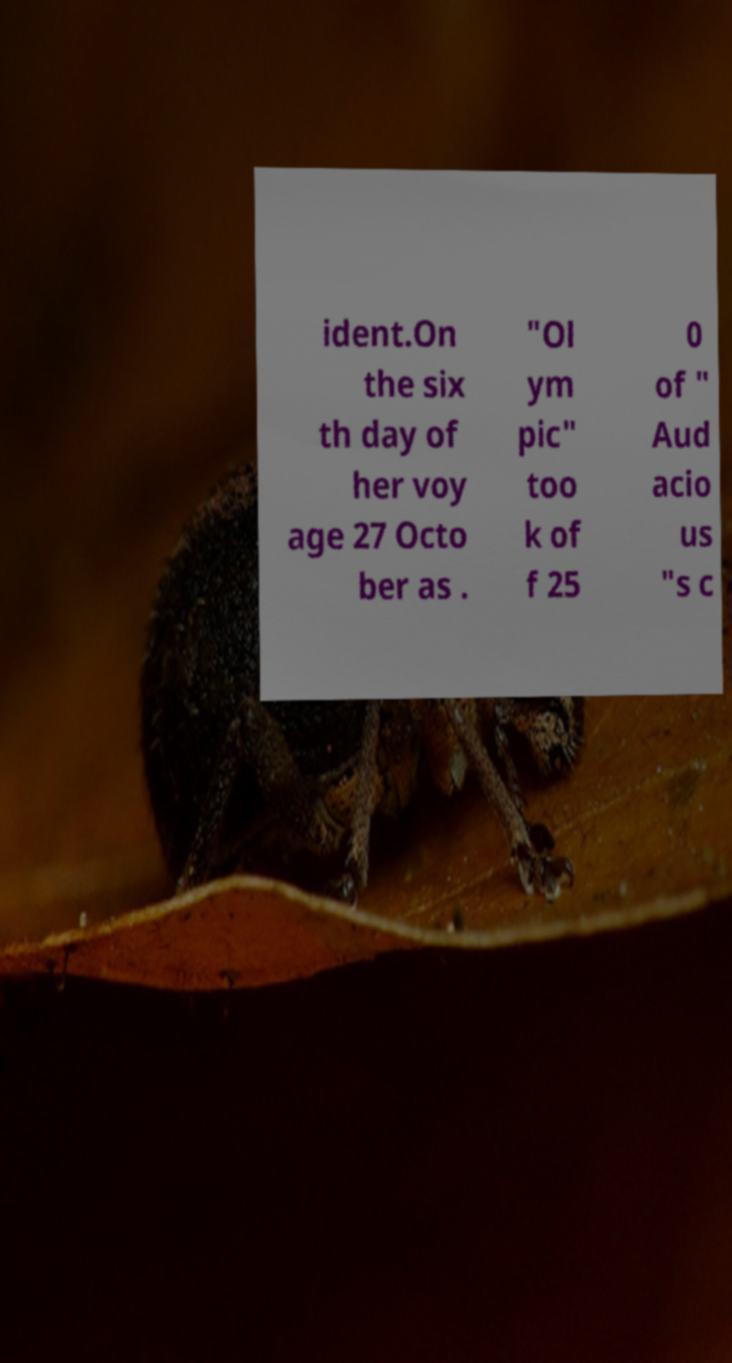Can you read and provide the text displayed in the image?This photo seems to have some interesting text. Can you extract and type it out for me? ident.On the six th day of her voy age 27 Octo ber as . "Ol ym pic" too k of f 25 0 of " Aud acio us "s c 